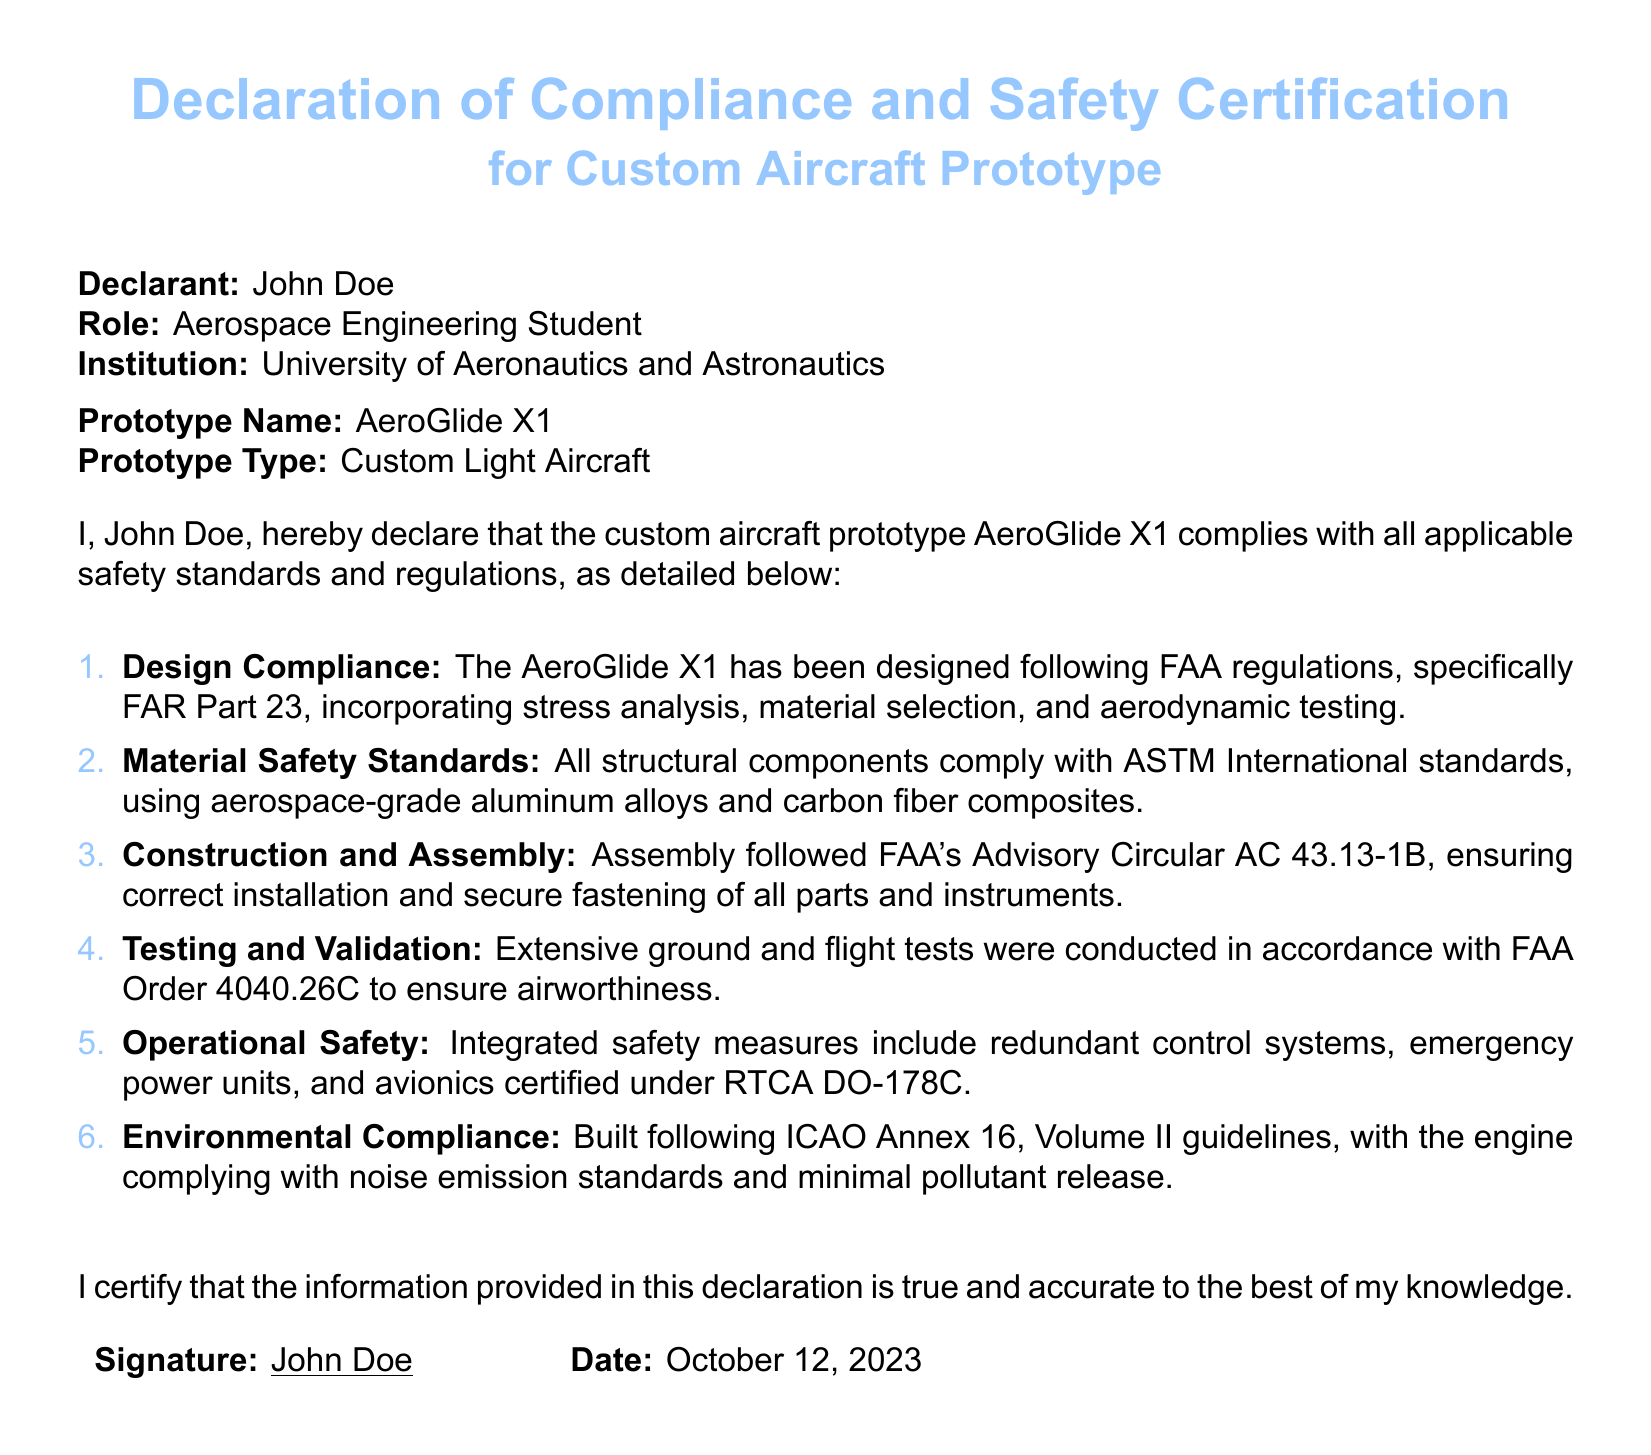What is the name of the declarant? The declarant is the person signing the document, which is John Doe.
Answer: John Doe What is the prototype name? The prototype name is listed under the prototype information, which is AeroGlide X1.
Answer: AeroGlide X1 What safety standards does the design comply with? The design compliance mentions FAA regulations, specifically FAR Part 23.
Answer: FAA regulations, FAR Part 23 What type of aircraft is the AeroGlide X1? The type of prototype specified is Custom Light Aircraft.
Answer: Custom Light Aircraft How many items are listed under testing and validation? The total number of items listed in the compliance sections provides insights into development, which gives us five specific compliance areas.
Answer: Five What is the date of signing? The date of signing is mentioned at the bottom of the document, which is October 12, 2023.
Answer: October 12, 2023 What is the material standard used for structural components? The safety standards for materials state compliance with ASTM International standards.
Answer: ASTM International standards What section includes designed safety measures? The operational safety section discusses integrated safety measures such as redundant control systems.
Answer: Operational Safety Who is the role of the declarant? The role is specified in the document and is identified as an Aerospace Engineering Student.
Answer: Aerospace Engineering Student 